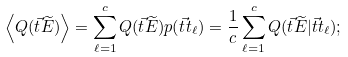Convert formula to latex. <formula><loc_0><loc_0><loc_500><loc_500>\left \langle Q ( \vec { t } { \widetilde { E } } ) \right \rangle = \sum _ { \ell = 1 } ^ { c } Q ( \vec { t } { \widetilde { E } } ) p ( \vec { t } { t } _ { \ell } ) = \frac { 1 } { c } \sum _ { \ell = 1 } ^ { c } Q ( \vec { t } { \widetilde { E } } | \vec { t } { t } _ { \ell } ) ;</formula> 